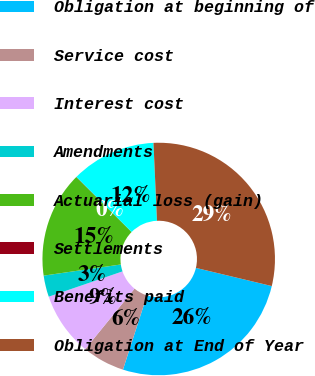Convert chart to OTSL. <chart><loc_0><loc_0><loc_500><loc_500><pie_chart><fcel>Obligation at beginning of<fcel>Service cost<fcel>Interest cost<fcel>Amendments<fcel>Actuarial loss (gain)<fcel>Settlements<fcel>Benefits paid<fcel>Obligation at End of Year<nl><fcel>26.24%<fcel>5.91%<fcel>8.86%<fcel>2.97%<fcel>14.74%<fcel>0.03%<fcel>11.8%<fcel>29.46%<nl></chart> 